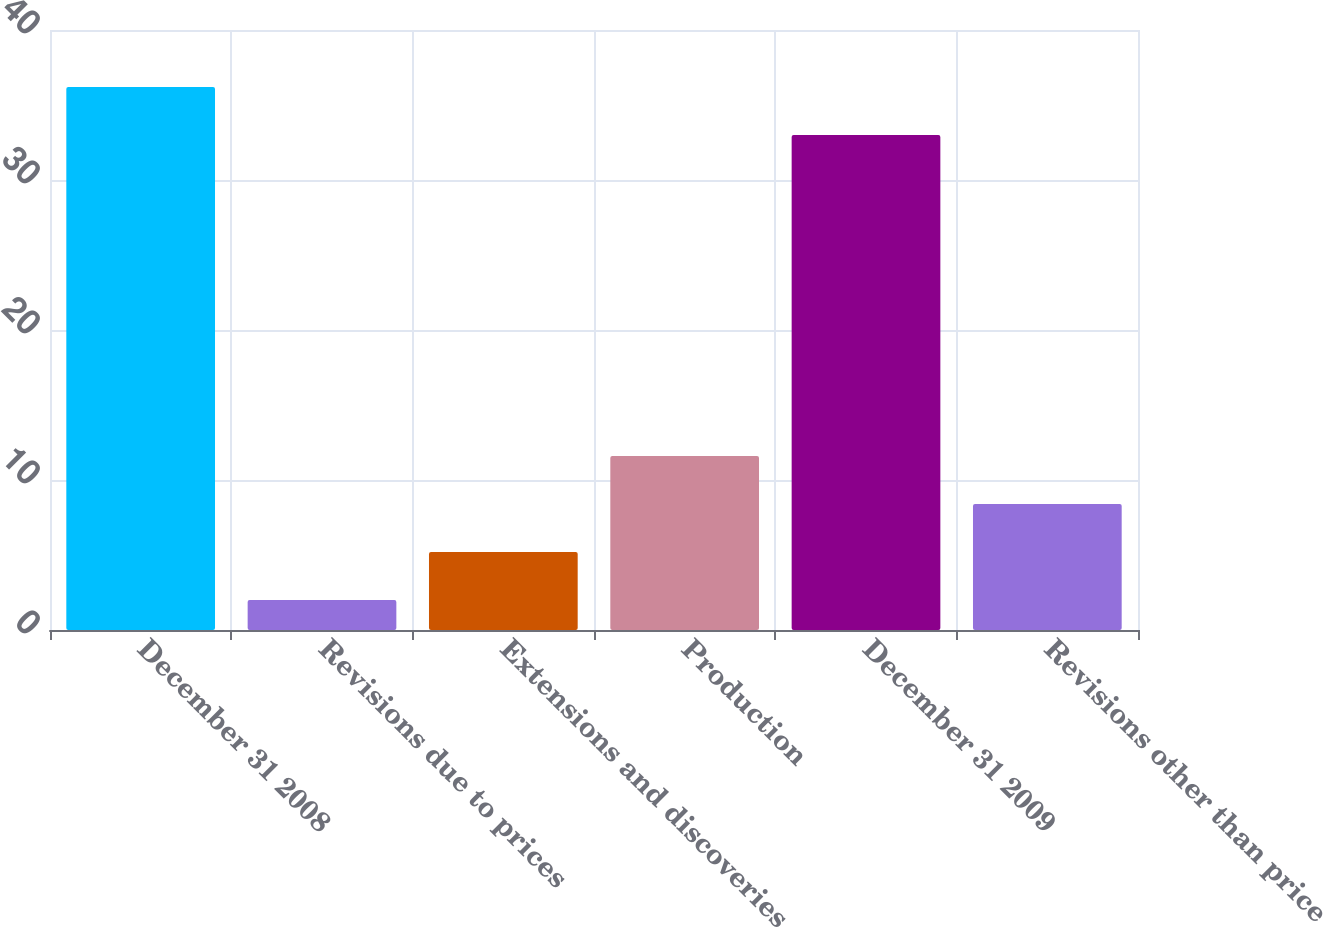Convert chart. <chart><loc_0><loc_0><loc_500><loc_500><bar_chart><fcel>December 31 2008<fcel>Revisions due to prices<fcel>Extensions and discoveries<fcel>Production<fcel>December 31 2009<fcel>Revisions other than price<nl><fcel>36.2<fcel>2<fcel>5.2<fcel>11.6<fcel>33<fcel>8.4<nl></chart> 